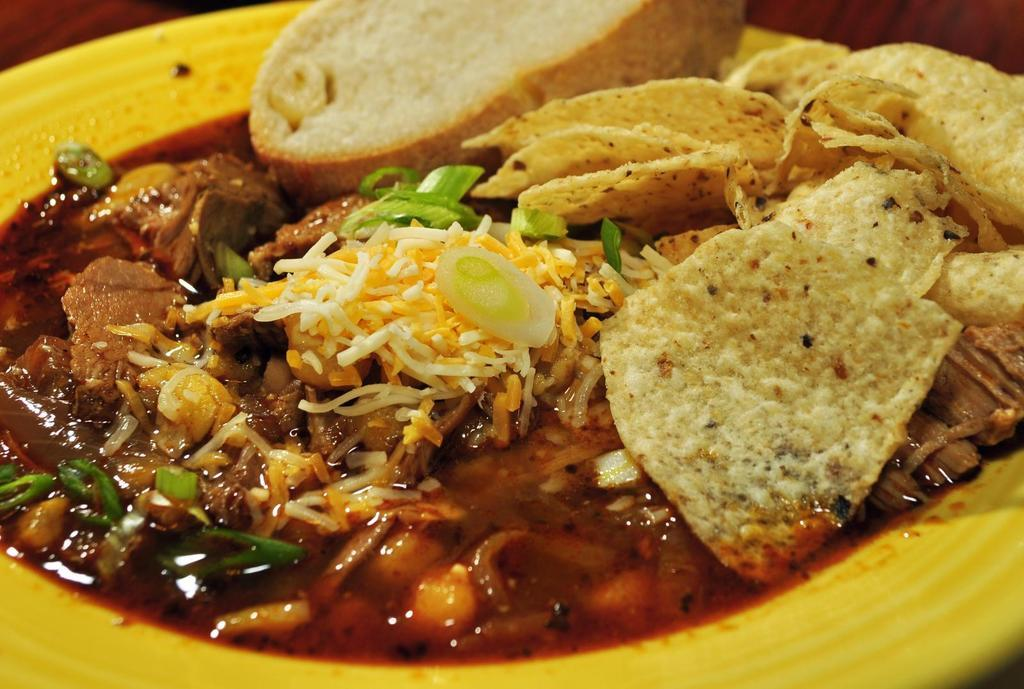What is present in the image related to food? There is food in the image. How is the food arranged or contained? The food is in a plate. Where is the plate with food located? The plate is placed on a surface. What type of knife is used to cut the food in the image? There is no knife present in the image; only food in a plate is visible. 